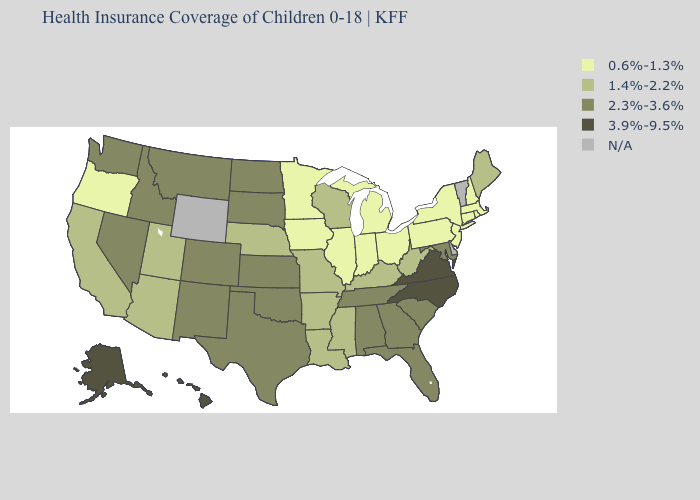Among the states that border Mississippi , which have the highest value?
Be succinct. Alabama, Tennessee. Among the states that border Texas , which have the highest value?
Quick response, please. New Mexico, Oklahoma. Which states hav the highest value in the South?
Short answer required. North Carolina, Virginia. Name the states that have a value in the range 1.4%-2.2%?
Quick response, please. Arizona, Arkansas, California, Kentucky, Louisiana, Maine, Mississippi, Missouri, Nebraska, Utah, West Virginia, Wisconsin. What is the value of Texas?
Short answer required. 2.3%-3.6%. What is the lowest value in states that border New Mexico?
Give a very brief answer. 1.4%-2.2%. Name the states that have a value in the range N/A?
Write a very short answer. Delaware, Vermont, Wyoming. What is the value of Rhode Island?
Short answer required. 0.6%-1.3%. Name the states that have a value in the range N/A?
Quick response, please. Delaware, Vermont, Wyoming. Name the states that have a value in the range 1.4%-2.2%?
Quick response, please. Arizona, Arkansas, California, Kentucky, Louisiana, Maine, Mississippi, Missouri, Nebraska, Utah, West Virginia, Wisconsin. What is the value of Minnesota?
Keep it brief. 0.6%-1.3%. What is the value of New York?
Write a very short answer. 0.6%-1.3%. Among the states that border Michigan , does Wisconsin have the lowest value?
Keep it brief. No. 